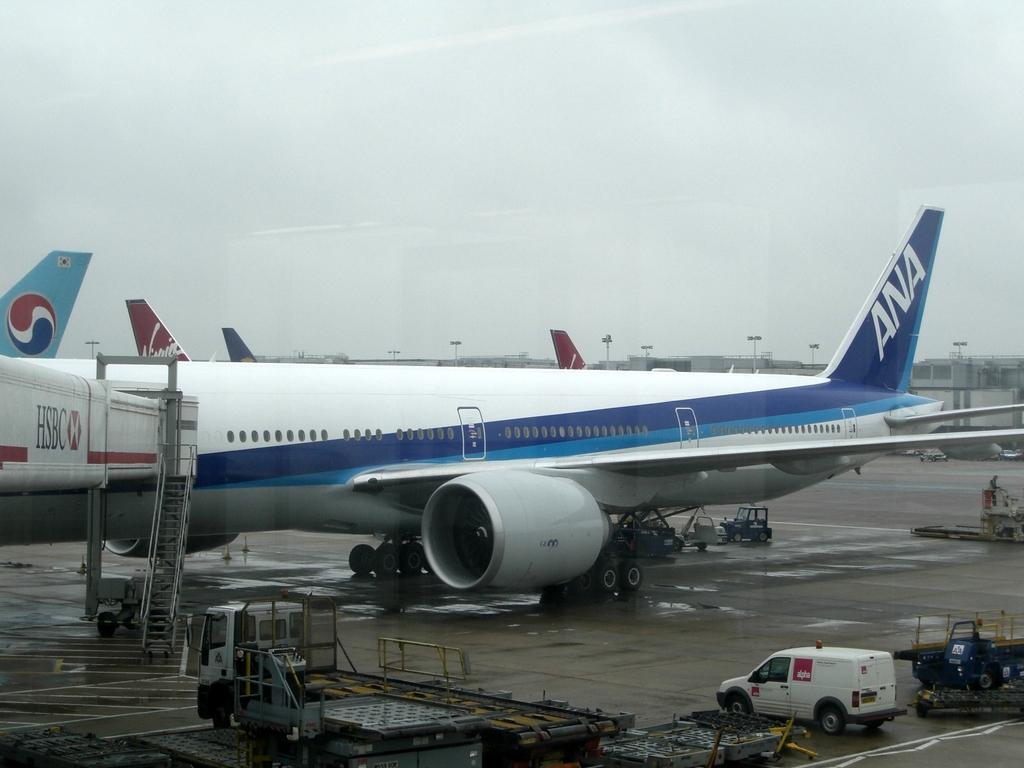Can you describe this image briefly? The picture is taken in an airport. In the foreground of the picture there are vehicles. In the center of the picture there are airplanes and other vehicles. In the background there are lights and buildings. Sky is cloudy. 